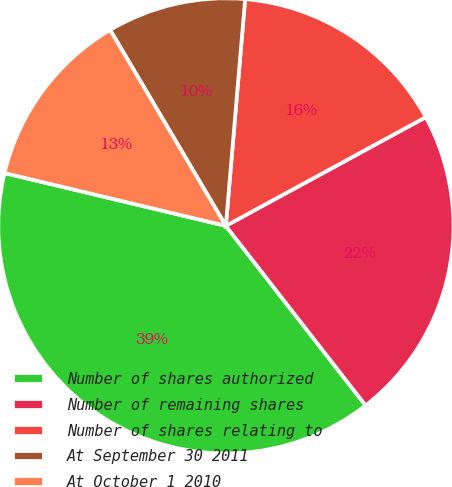<chart> <loc_0><loc_0><loc_500><loc_500><pie_chart><fcel>Number of shares authorized<fcel>Number of remaining shares<fcel>Number of shares relating to<fcel>At September 30 2011<fcel>At October 1 2010<nl><fcel>39.25%<fcel>22.4%<fcel>15.72%<fcel>9.84%<fcel>12.78%<nl></chart> 